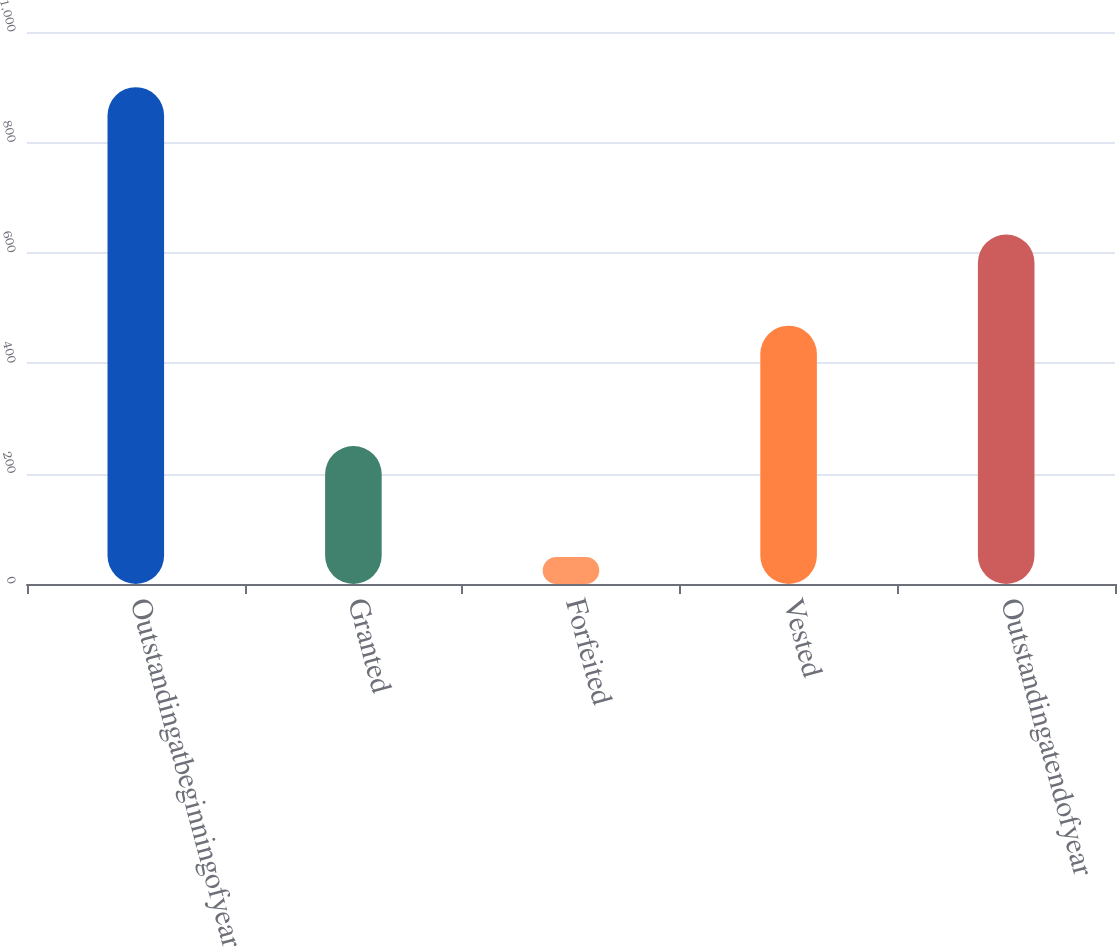Convert chart to OTSL. <chart><loc_0><loc_0><loc_500><loc_500><bar_chart><fcel>Outstandingatbeginningofyear<fcel>Granted<fcel>Forfeited<fcel>Vested<fcel>Outstandingatendofyear<nl><fcel>900<fcel>250<fcel>49<fcel>468<fcel>633<nl></chart> 